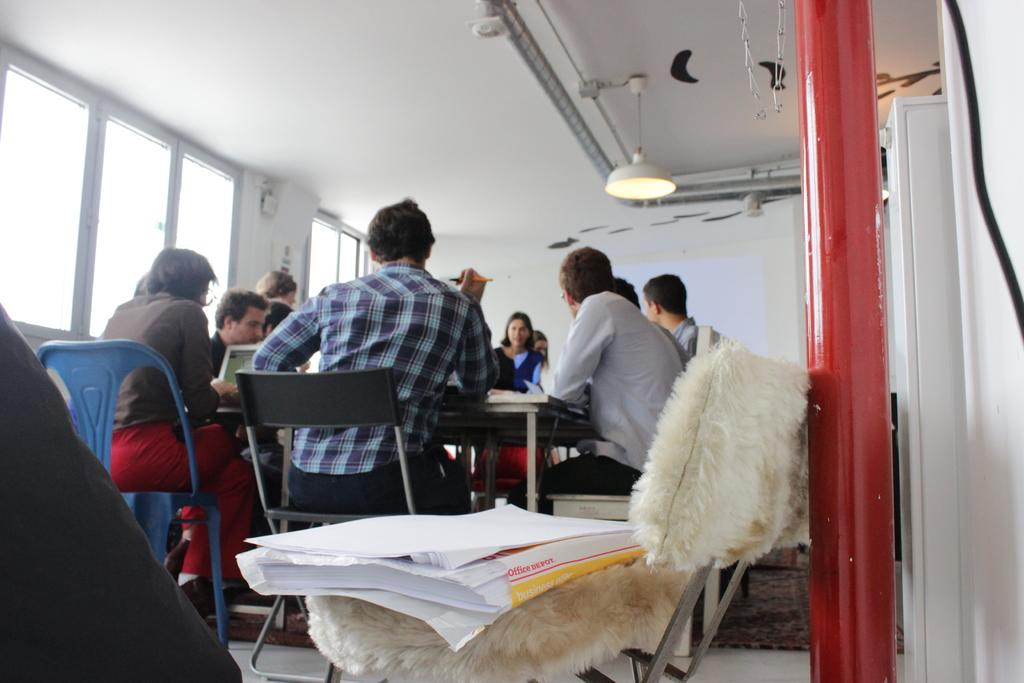How many people are in the image? There is a group of people in the image. What are the people doing in the image? The people are sitting in chairs. What is present in the image besides the people? There is a table, a light, a wall, a window, books on a chair, and a pole in the background. Is there a sack of potatoes visible in the image? No, there is no sack of potatoes present in the image. 